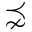<formula> <loc_0><loc_0><loc_500><loc_500>\precnsim</formula> 